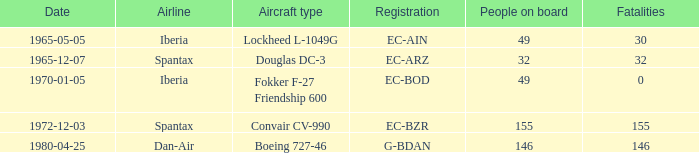How many fatalities shows for the lockheed l-1049g? 30.0. 